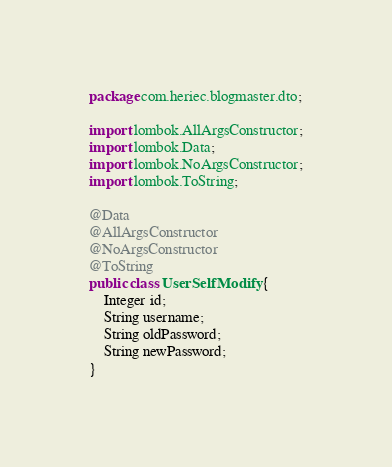Convert code to text. <code><loc_0><loc_0><loc_500><loc_500><_Java_>package com.heriec.blogmaster.dto;

import lombok.AllArgsConstructor;
import lombok.Data;
import lombok.NoArgsConstructor;
import lombok.ToString;

@Data
@AllArgsConstructor
@NoArgsConstructor
@ToString
public class UserSelfModify {
    Integer id;
    String username;
    String oldPassword;
    String newPassword;
}
</code> 